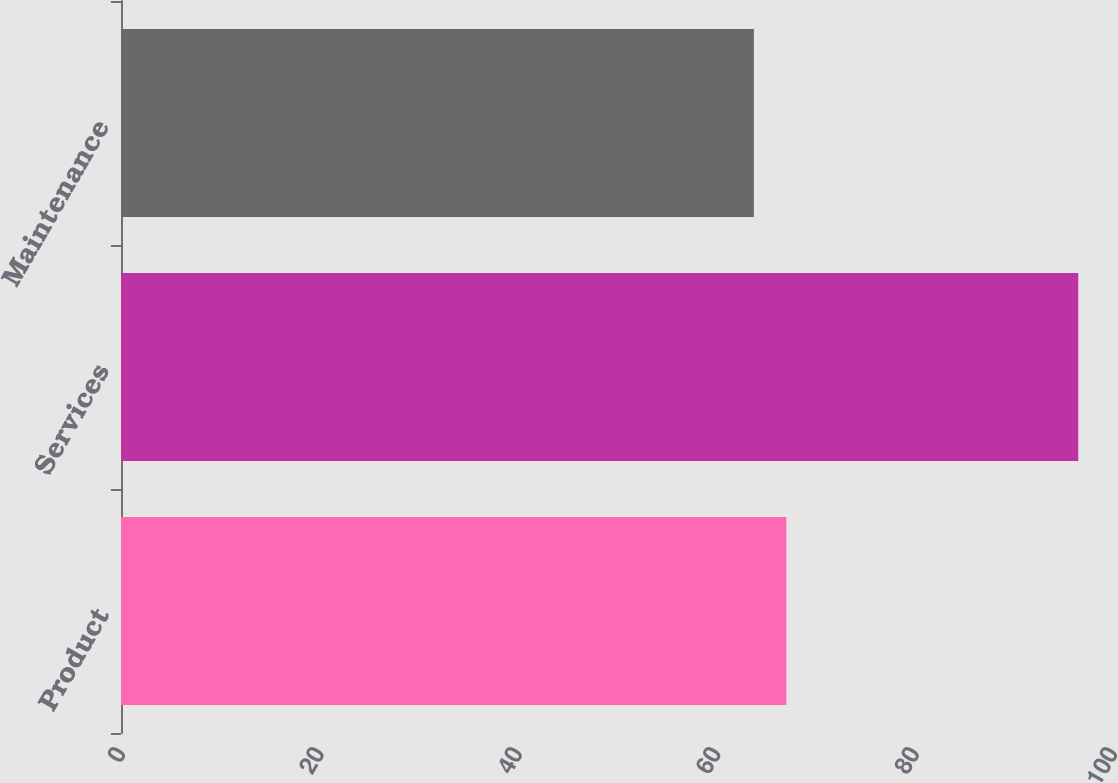<chart> <loc_0><loc_0><loc_500><loc_500><bar_chart><fcel>Product<fcel>Services<fcel>Maintenance<nl><fcel>67.07<fcel>96.5<fcel>63.8<nl></chart> 